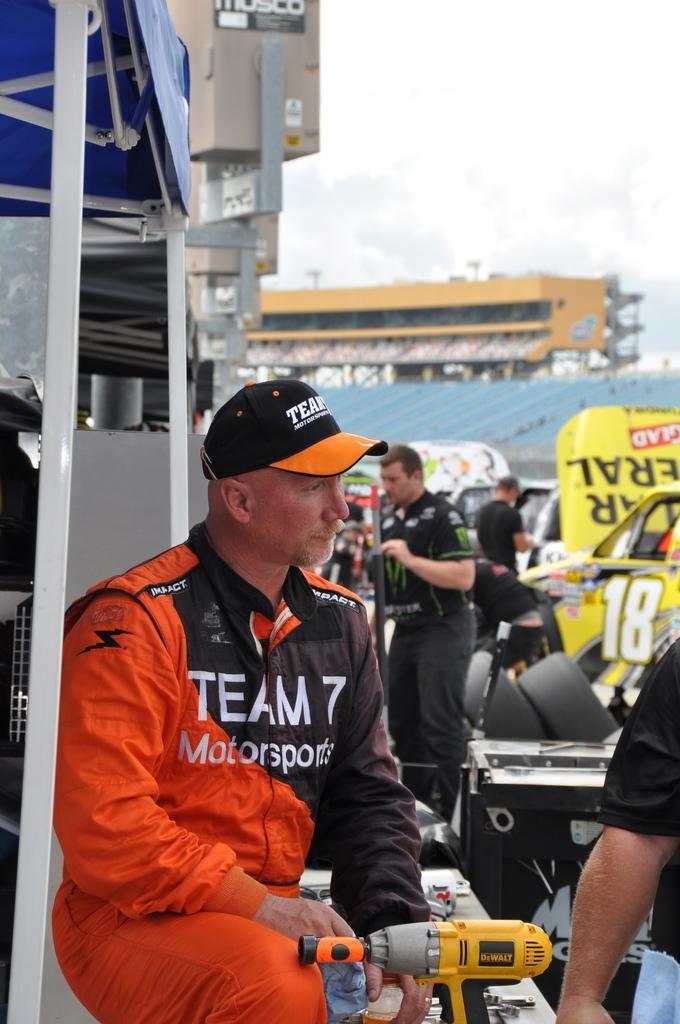In one or two sentences, can you explain what this image depicts? On the left side there is a tent, in front of the tent there is a man standing and there are tools, in the background there are people standing and there are cars and it is blurred. 